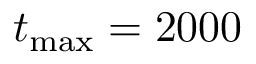Convert formula to latex. <formula><loc_0><loc_0><loc_500><loc_500>t _ { \max } = 2 0 0 0</formula> 